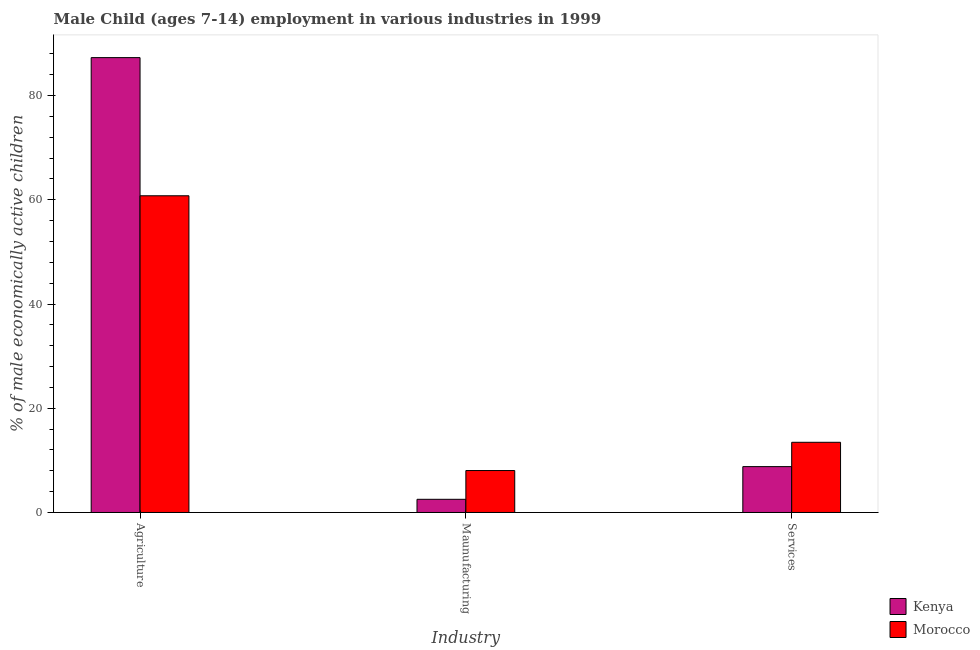How many different coloured bars are there?
Offer a terse response. 2. How many groups of bars are there?
Offer a terse response. 3. Are the number of bars per tick equal to the number of legend labels?
Your answer should be very brief. Yes. Are the number of bars on each tick of the X-axis equal?
Provide a succinct answer. Yes. How many bars are there on the 3rd tick from the left?
Give a very brief answer. 2. What is the label of the 3rd group of bars from the left?
Your answer should be very brief. Services. What is the percentage of economically active children in agriculture in Morocco?
Keep it short and to the point. 60.78. Across all countries, what is the maximum percentage of economically active children in manufacturing?
Provide a short and direct response. 8.05. Across all countries, what is the minimum percentage of economically active children in services?
Provide a short and direct response. 8.8. In which country was the percentage of economically active children in manufacturing maximum?
Give a very brief answer. Morocco. In which country was the percentage of economically active children in manufacturing minimum?
Give a very brief answer. Kenya. What is the total percentage of economically active children in services in the graph?
Offer a very short reply. 22.27. What is the difference between the percentage of economically active children in services in Kenya and that in Morocco?
Your response must be concise. -4.67. What is the difference between the percentage of economically active children in agriculture in Kenya and the percentage of economically active children in services in Morocco?
Offer a very short reply. 73.82. What is the average percentage of economically active children in manufacturing per country?
Offer a very short reply. 5.29. What is the difference between the percentage of economically active children in services and percentage of economically active children in agriculture in Morocco?
Ensure brevity in your answer.  -47.31. In how many countries, is the percentage of economically active children in manufacturing greater than 4 %?
Make the answer very short. 1. What is the ratio of the percentage of economically active children in services in Kenya to that in Morocco?
Your response must be concise. 0.65. Is the percentage of economically active children in services in Morocco less than that in Kenya?
Offer a terse response. No. Is the difference between the percentage of economically active children in manufacturing in Kenya and Morocco greater than the difference between the percentage of economically active children in services in Kenya and Morocco?
Your response must be concise. No. What is the difference between the highest and the second highest percentage of economically active children in agriculture?
Your answer should be very brief. 26.51. What is the difference between the highest and the lowest percentage of economically active children in agriculture?
Make the answer very short. 26.51. In how many countries, is the percentage of economically active children in services greater than the average percentage of economically active children in services taken over all countries?
Your answer should be very brief. 1. Is the sum of the percentage of economically active children in manufacturing in Kenya and Morocco greater than the maximum percentage of economically active children in services across all countries?
Give a very brief answer. No. What does the 1st bar from the left in Agriculture represents?
Offer a terse response. Kenya. What does the 1st bar from the right in Maunufacturing represents?
Your answer should be very brief. Morocco. Is it the case that in every country, the sum of the percentage of economically active children in agriculture and percentage of economically active children in manufacturing is greater than the percentage of economically active children in services?
Your answer should be very brief. Yes. How many bars are there?
Ensure brevity in your answer.  6. How many countries are there in the graph?
Your response must be concise. 2. Are the values on the major ticks of Y-axis written in scientific E-notation?
Ensure brevity in your answer.  No. Where does the legend appear in the graph?
Your response must be concise. Bottom right. How many legend labels are there?
Offer a very short reply. 2. What is the title of the graph?
Keep it short and to the point. Male Child (ages 7-14) employment in various industries in 1999. What is the label or title of the X-axis?
Your answer should be compact. Industry. What is the label or title of the Y-axis?
Ensure brevity in your answer.  % of male economically active children. What is the % of male economically active children of Kenya in Agriculture?
Keep it short and to the point. 87.29. What is the % of male economically active children of Morocco in Agriculture?
Give a very brief answer. 60.78. What is the % of male economically active children in Kenya in Maunufacturing?
Offer a terse response. 2.53. What is the % of male economically active children of Morocco in Maunufacturing?
Give a very brief answer. 8.05. What is the % of male economically active children of Kenya in Services?
Your answer should be very brief. 8.8. What is the % of male economically active children in Morocco in Services?
Offer a terse response. 13.47. Across all Industry, what is the maximum % of male economically active children in Kenya?
Your answer should be very brief. 87.29. Across all Industry, what is the maximum % of male economically active children in Morocco?
Ensure brevity in your answer.  60.78. Across all Industry, what is the minimum % of male economically active children in Kenya?
Offer a very short reply. 2.53. Across all Industry, what is the minimum % of male economically active children of Morocco?
Make the answer very short. 8.05. What is the total % of male economically active children in Kenya in the graph?
Your response must be concise. 98.62. What is the total % of male economically active children of Morocco in the graph?
Your answer should be very brief. 82.3. What is the difference between the % of male economically active children of Kenya in Agriculture and that in Maunufacturing?
Ensure brevity in your answer.  84.76. What is the difference between the % of male economically active children of Morocco in Agriculture and that in Maunufacturing?
Your answer should be very brief. 52.73. What is the difference between the % of male economically active children of Kenya in Agriculture and that in Services?
Keep it short and to the point. 78.49. What is the difference between the % of male economically active children in Morocco in Agriculture and that in Services?
Give a very brief answer. 47.31. What is the difference between the % of male economically active children of Kenya in Maunufacturing and that in Services?
Ensure brevity in your answer.  -6.27. What is the difference between the % of male economically active children of Morocco in Maunufacturing and that in Services?
Offer a very short reply. -5.42. What is the difference between the % of male economically active children of Kenya in Agriculture and the % of male economically active children of Morocco in Maunufacturing?
Make the answer very short. 79.24. What is the difference between the % of male economically active children of Kenya in Agriculture and the % of male economically active children of Morocco in Services?
Your response must be concise. 73.82. What is the difference between the % of male economically active children of Kenya in Maunufacturing and the % of male economically active children of Morocco in Services?
Provide a short and direct response. -10.94. What is the average % of male economically active children in Kenya per Industry?
Offer a very short reply. 32.87. What is the average % of male economically active children of Morocco per Industry?
Your response must be concise. 27.43. What is the difference between the % of male economically active children in Kenya and % of male economically active children in Morocco in Agriculture?
Offer a terse response. 26.51. What is the difference between the % of male economically active children of Kenya and % of male economically active children of Morocco in Maunufacturing?
Your response must be concise. -5.52. What is the difference between the % of male economically active children of Kenya and % of male economically active children of Morocco in Services?
Offer a terse response. -4.67. What is the ratio of the % of male economically active children of Kenya in Agriculture to that in Maunufacturing?
Your answer should be compact. 34.51. What is the ratio of the % of male economically active children of Morocco in Agriculture to that in Maunufacturing?
Make the answer very short. 7.55. What is the ratio of the % of male economically active children of Kenya in Agriculture to that in Services?
Your response must be concise. 9.92. What is the ratio of the % of male economically active children of Morocco in Agriculture to that in Services?
Keep it short and to the point. 4.51. What is the ratio of the % of male economically active children of Kenya in Maunufacturing to that in Services?
Provide a succinct answer. 0.29. What is the ratio of the % of male economically active children of Morocco in Maunufacturing to that in Services?
Your response must be concise. 0.6. What is the difference between the highest and the second highest % of male economically active children of Kenya?
Provide a succinct answer. 78.49. What is the difference between the highest and the second highest % of male economically active children of Morocco?
Offer a very short reply. 47.31. What is the difference between the highest and the lowest % of male economically active children in Kenya?
Your answer should be compact. 84.76. What is the difference between the highest and the lowest % of male economically active children in Morocco?
Keep it short and to the point. 52.73. 